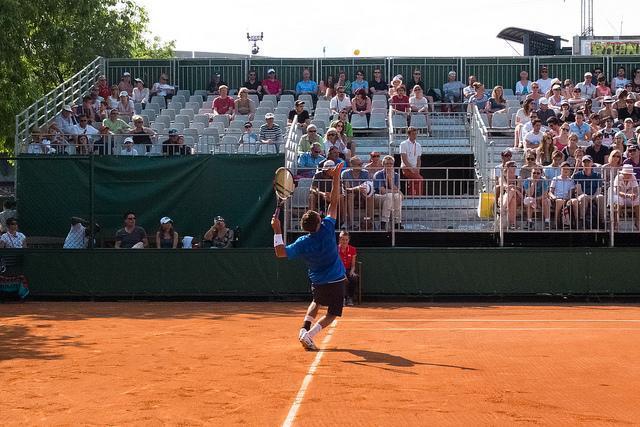How many people can you see?
Give a very brief answer. 2. 